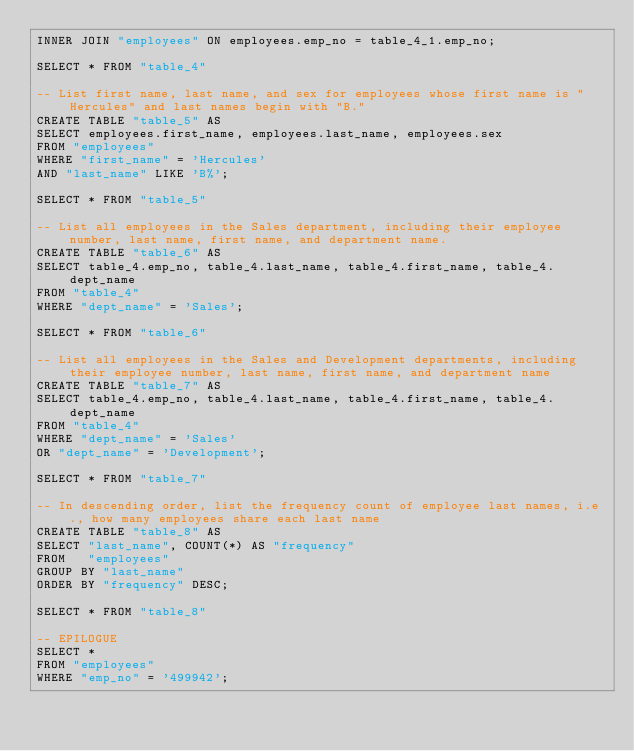Convert code to text. <code><loc_0><loc_0><loc_500><loc_500><_SQL_>INNER JOIN "employees" ON employees.emp_no = table_4_1.emp_no;

SELECT * FROM "table_4"

-- List first name, last name, and sex for employees whose first name is "Hercules" and last names begin with "B."
CREATE TABLE "table_5" AS
SELECT employees.first_name, employees.last_name, employees.sex
FROM "employees"
WHERE "first_name" = 'Hercules'
AND "last_name" LIKE 'B%';

SELECT * FROM "table_5"

-- List all employees in the Sales department, including their employee number, last name, first name, and department name.
CREATE TABLE "table_6" AS
SELECT table_4.emp_no, table_4.last_name, table_4.first_name, table_4.dept_name
FROM "table_4"
WHERE "dept_name" = 'Sales';

SELECT * FROM "table_6"

-- List all employees in the Sales and Development departments, including their employee number, last name, first name, and department name
CREATE TABLE "table_7" AS
SELECT table_4.emp_no, table_4.last_name, table_4.first_name, table_4.dept_name
FROM "table_4"
WHERE "dept_name" = 'Sales'
OR "dept_name" = 'Development';

SELECT * FROM "table_7"

-- In descending order, list the frequency count of employee last names, i.e., how many employees share each last name
CREATE TABLE "table_8" AS
SELECT "last_name", COUNT(*) AS "frequency"
FROM   "employees"
GROUP BY "last_name"
ORDER BY "frequency" DESC;

SELECT * FROM "table_8"

-- EPILOGUE
SELECT *
FROM "employees"
WHERE "emp_no" = '499942';

</code> 